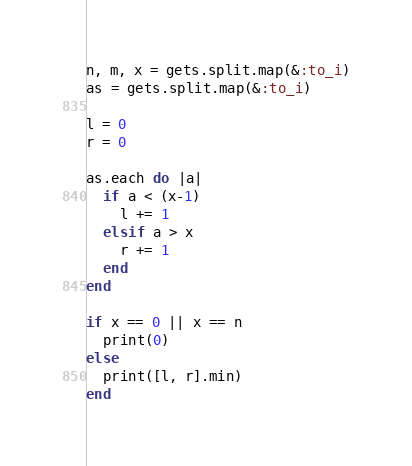<code> <loc_0><loc_0><loc_500><loc_500><_Ruby_>n, m, x = gets.split.map(&:to_i)
as = gets.split.map(&:to_i)

l = 0
r = 0

as.each do |a|
  if a < (x-1)
    l += 1
  elsif a > x
    r += 1
  end
end

if x == 0 || x == n
  print(0)
else
  print([l, r].min)
end
</code> 